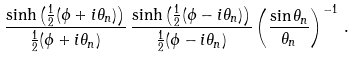Convert formula to latex. <formula><loc_0><loc_0><loc_500><loc_500>\frac { \sinh \left ( \frac { 1 } { 2 } ( \phi + i \theta _ { n } ) \right ) } { \frac { 1 } { 2 } ( \phi + i \theta _ { n } ) } \, \frac { \sinh \left ( \frac { 1 } { 2 } ( \phi - i \theta _ { n } ) \right ) } { \frac { 1 } { 2 } ( \phi - i \theta _ { n } ) } \left ( \frac { \sin \theta _ { n } } { \theta _ { n } } \right ) ^ { - 1 } \, .</formula> 